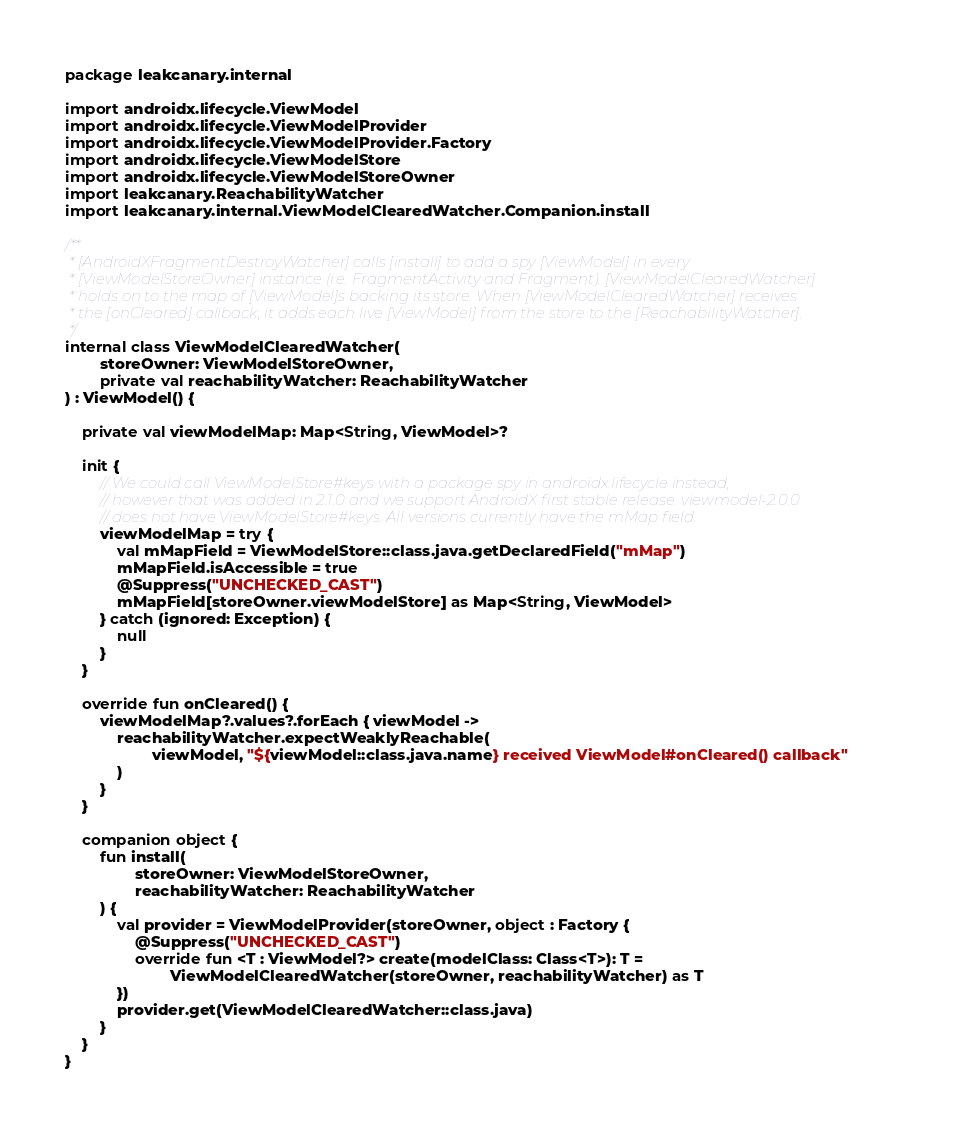Convert code to text. <code><loc_0><loc_0><loc_500><loc_500><_Kotlin_>package leakcanary.internal

import androidx.lifecycle.ViewModel
import androidx.lifecycle.ViewModelProvider
import androidx.lifecycle.ViewModelProvider.Factory
import androidx.lifecycle.ViewModelStore
import androidx.lifecycle.ViewModelStoreOwner
import leakcanary.ReachabilityWatcher
import leakcanary.internal.ViewModelClearedWatcher.Companion.install

/**
 * [AndroidXFragmentDestroyWatcher] calls [install] to add a spy [ViewModel] in every
 * [ViewModelStoreOwner] instance (i.e. FragmentActivity and Fragment). [ViewModelClearedWatcher]
 * holds on to the map of [ViewModel]s backing its store. When [ViewModelClearedWatcher] receives
 * the [onCleared] callback, it adds each live [ViewModel] from the store to the [ReachabilityWatcher].
 */
internal class ViewModelClearedWatcher(
        storeOwner: ViewModelStoreOwner,
        private val reachabilityWatcher: ReachabilityWatcher
) : ViewModel() {

    private val viewModelMap: Map<String, ViewModel>?

    init {
        // We could call ViewModelStore#keys with a package spy in androidx.lifecycle instead,
        // however that was added in 2.1.0 and we support AndroidX first stable release. viewmodel-2.0.0
        // does not have ViewModelStore#keys. All versions currently have the mMap field.
        viewModelMap = try {
            val mMapField = ViewModelStore::class.java.getDeclaredField("mMap")
            mMapField.isAccessible = true
            @Suppress("UNCHECKED_CAST")
            mMapField[storeOwner.viewModelStore] as Map<String, ViewModel>
        } catch (ignored: Exception) {
            null
        }
    }

    override fun onCleared() {
        viewModelMap?.values?.forEach { viewModel ->
            reachabilityWatcher.expectWeaklyReachable(
                    viewModel, "${viewModel::class.java.name} received ViewModel#onCleared() callback"
            )
        }
    }

    companion object {
        fun install(
                storeOwner: ViewModelStoreOwner,
                reachabilityWatcher: ReachabilityWatcher
        ) {
            val provider = ViewModelProvider(storeOwner, object : Factory {
                @Suppress("UNCHECKED_CAST")
                override fun <T : ViewModel?> create(modelClass: Class<T>): T =
                        ViewModelClearedWatcher(storeOwner, reachabilityWatcher) as T
            })
            provider.get(ViewModelClearedWatcher::class.java)
        }
    }
}</code> 